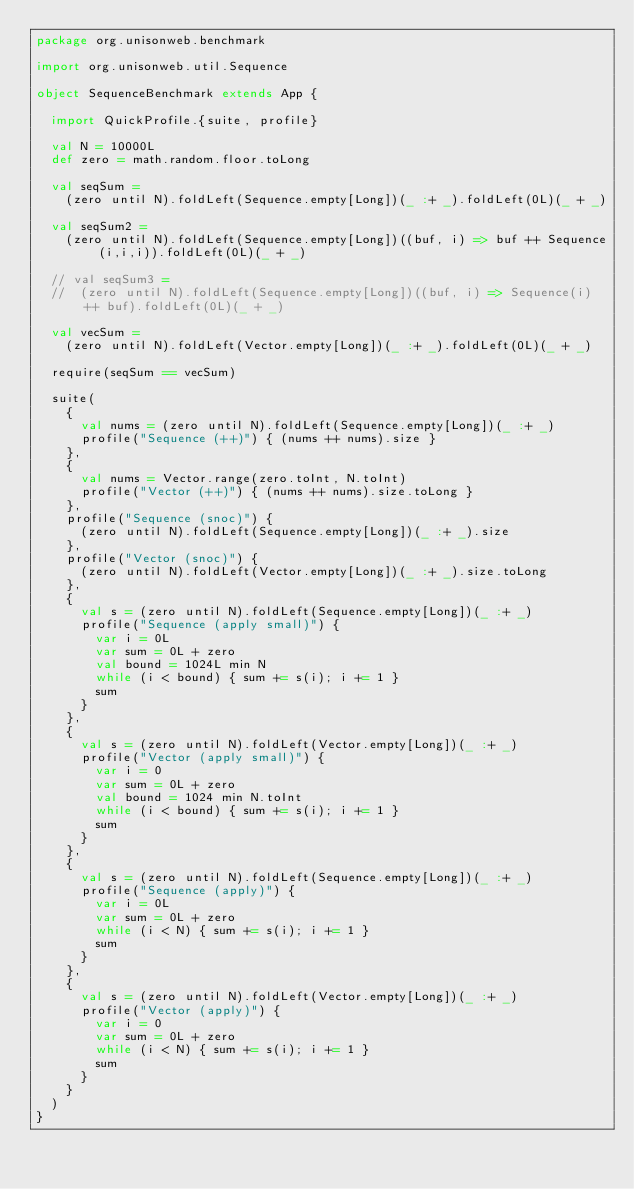Convert code to text. <code><loc_0><loc_0><loc_500><loc_500><_Scala_>package org.unisonweb.benchmark

import org.unisonweb.util.Sequence

object SequenceBenchmark extends App {

  import QuickProfile.{suite, profile}

  val N = 10000L
  def zero = math.random.floor.toLong

  val seqSum =
    (zero until N).foldLeft(Sequence.empty[Long])(_ :+ _).foldLeft(0L)(_ + _)

  val seqSum2 =
    (zero until N).foldLeft(Sequence.empty[Long])((buf, i) => buf ++ Sequence(i,i,i)).foldLeft(0L)(_ + _)

  // val seqSum3 =
  //  (zero until N).foldLeft(Sequence.empty[Long])((buf, i) => Sequence(i) ++ buf).foldLeft(0L)(_ + _)

  val vecSum =
    (zero until N).foldLeft(Vector.empty[Long])(_ :+ _).foldLeft(0L)(_ + _)

  require(seqSum == vecSum)

  suite(
    {
      val nums = (zero until N).foldLeft(Sequence.empty[Long])(_ :+ _)
      profile("Sequence (++)") { (nums ++ nums).size }
    },
    {
      val nums = Vector.range(zero.toInt, N.toInt)
      profile("Vector (++)") { (nums ++ nums).size.toLong }
    },
    profile("Sequence (snoc)") {
      (zero until N).foldLeft(Sequence.empty[Long])(_ :+ _).size
    },
    profile("Vector (snoc)") {
      (zero until N).foldLeft(Vector.empty[Long])(_ :+ _).size.toLong
    },
    {
      val s = (zero until N).foldLeft(Sequence.empty[Long])(_ :+ _)
      profile("Sequence (apply small)") {
        var i = 0L
        var sum = 0L + zero
        val bound = 1024L min N
        while (i < bound) { sum += s(i); i += 1 }
        sum
      }
    },
    {
      val s = (zero until N).foldLeft(Vector.empty[Long])(_ :+ _)
      profile("Vector (apply small)") {
        var i = 0
        var sum = 0L + zero
        val bound = 1024 min N.toInt
        while (i < bound) { sum += s(i); i += 1 }
        sum
      }
    },
    {
      val s = (zero until N).foldLeft(Sequence.empty[Long])(_ :+ _)
      profile("Sequence (apply)") {
        var i = 0L
        var sum = 0L + zero
        while (i < N) { sum += s(i); i += 1 }
        sum
      }
    },
    {
      val s = (zero until N).foldLeft(Vector.empty[Long])(_ :+ _)
      profile("Vector (apply)") {
        var i = 0
        var sum = 0L + zero
        while (i < N) { sum += s(i); i += 1 }
        sum
      }
    }
  )
}
</code> 